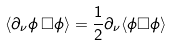Convert formula to latex. <formula><loc_0><loc_0><loc_500><loc_500>\langle \partial _ { \nu } \phi \, \Box \phi \rangle = \frac { 1 } { 2 } \partial _ { \nu } \langle \phi \Box \phi \rangle</formula> 